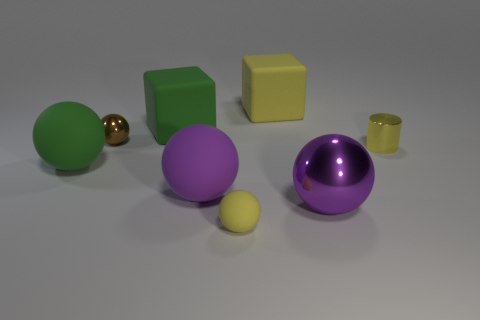Is there anything else that has the same shape as the yellow metal thing?
Your answer should be compact. No. Is the number of yellow rubber blocks greater than the number of blue matte cubes?
Offer a very short reply. Yes. How many objects are things that are to the left of the tiny yellow cylinder or balls that are behind the tiny yellow metal thing?
Make the answer very short. 7. What is the color of the metallic sphere that is the same size as the yellow block?
Provide a short and direct response. Purple. Is the yellow block made of the same material as the small cylinder?
Your response must be concise. No. What material is the yellow object in front of the purple thing on the left side of the small rubber sphere?
Make the answer very short. Rubber. Are there more shiny things in front of the small matte thing than green rubber blocks?
Provide a succinct answer. No. How many other objects are there of the same size as the green matte sphere?
Your answer should be very brief. 4. Is the color of the tiny shiny cylinder the same as the large metal ball?
Give a very brief answer. No. There is a tiny ball in front of the metal sphere that is right of the purple thing that is behind the large metal ball; what is its color?
Offer a terse response. Yellow. 